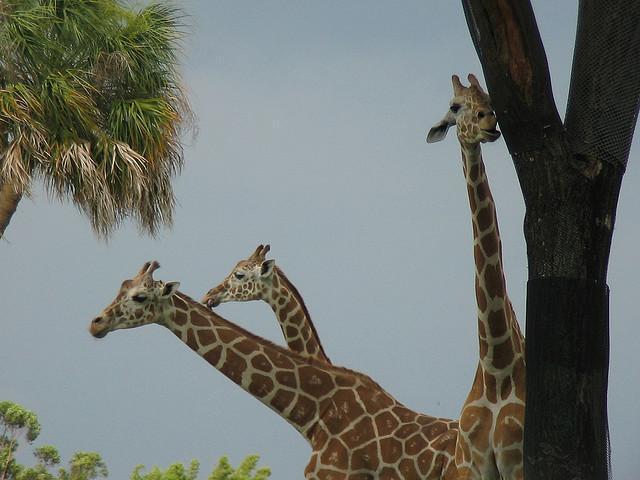How many animals are shown?
Give a very brief answer. 3. How many animals?
Give a very brief answer. 3. How many giraffes are there?
Give a very brief answer. 3. How many women are hugging the fire hydrant?
Give a very brief answer. 0. 